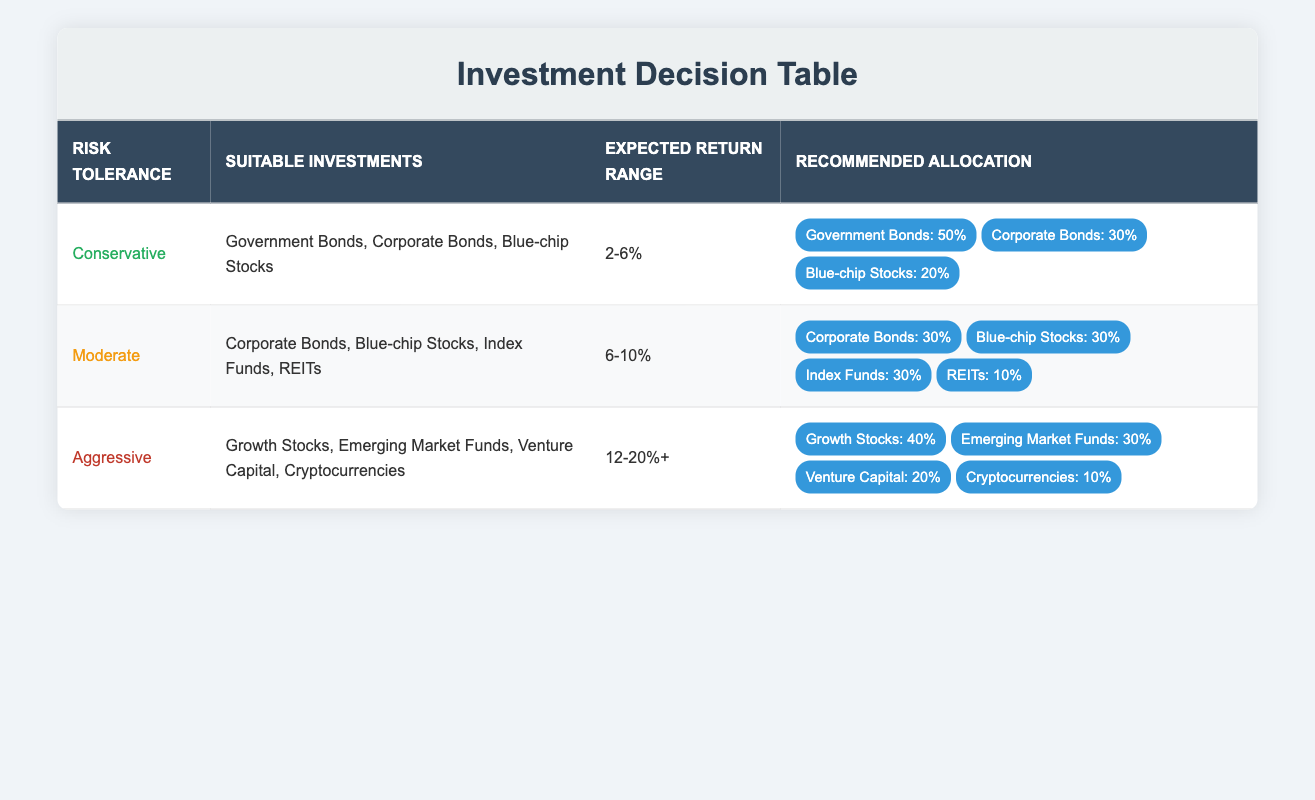What are the suitable investments for a conservative risk tolerance? The table lists "Government Bonds, Corporate Bonds, Blue-chip Stocks" as the suitable investments for a conservative risk tolerance level. This information can be found directly under the 'Suitable Investments' column corresponding to the 'Conservative' row.
Answer: Government Bonds, Corporate Bonds, Blue-chip Stocks What is the expected return range for moderate investors? The expected return range for moderate investors is stated under the 'Expected Return Range' column in the 'Moderate' row, which is "6-10%."
Answer: 6-10% Which investment has the highest recommended allocation for aggressive investors? In the 'Aggressive' row, the recommended allocation shows "Growth Stocks: 40%." The highest percentage indicates it is the most favored investment for aggressive investors.
Answer: Growth Stocks: 40% Are real estate investment trusts (REITs) suitable for conservative investors? The 'Suitable Investments' for conservative investors are clearly listed, and "REITs" is not included in that list. Therefore, REITs are not suitable.
Answer: No What is the total expected return range for investments suitable for moderate risk tolerance? For moderate risk tolerance, the suitable investments include assets expected to yield returns ranging from "6-10%." Therefore, this range is already provided and doesn't need combining with any other range, making it effectively stand as is.
Answer: 6-10% How would the allocation change for a moderate risk investor if they wanted to prioritize blue-chip stocks? The recommended allocation in the 'Moderate' row assigns 30% to Blue-chip stocks. If priority is given to blue-chip stocks, it implies a reallocation from other investments, potentially increasing this percentage beyond 30%, but specifics are not provided in the table.
Answer: Not specified Do aggressive investors have suitable investments with expected returns below 12%? The 'Aggressive' row lists expected returns of "12-20%+." All suitable investments for aggressive investors fall below this threshold, indicating no possibility of below 12%.
Answer: No What is the average recommended allocation for investment options under moderate risk tolerance? The recommended allocations for moderate risk tolerance are 30% for Corporate Bonds, 30% for Blue-chip Stocks, 30% for Index Funds, and 10% for REITs. To calculate the average, sum these percentages: (30 + 30 + 30 + 10) = 100; now divide by 4 investments, resulting in 100 / 4 = 25%.
Answer: 25% 